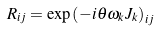<formula> <loc_0><loc_0><loc_500><loc_500>R _ { i j } = \exp \left ( - i \theta \omega _ { k } J _ { k } \right ) _ { i j }</formula> 